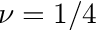<formula> <loc_0><loc_0><loc_500><loc_500>\nu = 1 / 4</formula> 